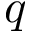<formula> <loc_0><loc_0><loc_500><loc_500>q</formula> 